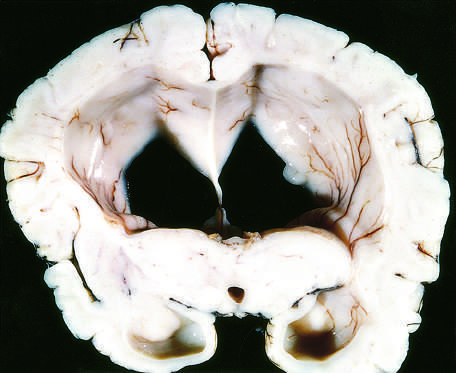re the segregation of b cells and t cells in different regions of the lymph node flattened as a result of compression of the expanding brain by the dura mater and inner surface of the skull?
Answer the question using a single word or phrase. No 